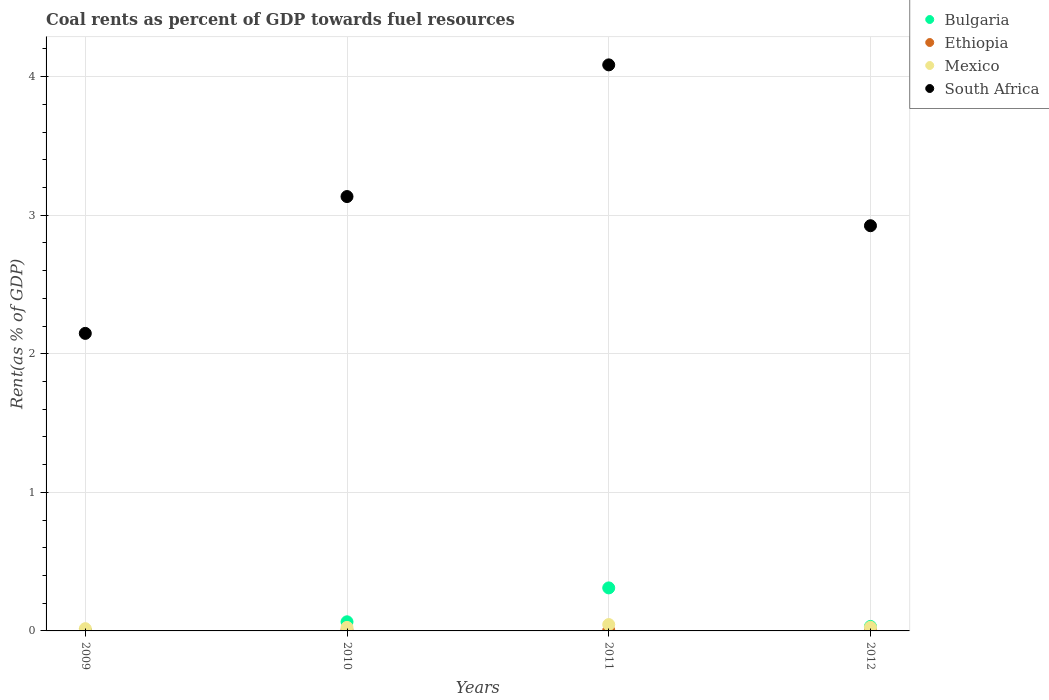Is the number of dotlines equal to the number of legend labels?
Offer a very short reply. Yes. What is the coal rent in Mexico in 2010?
Keep it short and to the point. 0.03. Across all years, what is the maximum coal rent in South Africa?
Make the answer very short. 4.08. Across all years, what is the minimum coal rent in Mexico?
Your response must be concise. 0.02. In which year was the coal rent in Mexico maximum?
Offer a terse response. 2011. What is the total coal rent in Bulgaria in the graph?
Provide a succinct answer. 0.41. What is the difference between the coal rent in Ethiopia in 2011 and that in 2012?
Your response must be concise. 0. What is the difference between the coal rent in South Africa in 2011 and the coal rent in Ethiopia in 2009?
Make the answer very short. 4.08. What is the average coal rent in Bulgaria per year?
Offer a very short reply. 0.1. In the year 2010, what is the difference between the coal rent in Mexico and coal rent in South Africa?
Your response must be concise. -3.11. In how many years, is the coal rent in Bulgaria greater than 2.6 %?
Your answer should be very brief. 0. What is the ratio of the coal rent in South Africa in 2009 to that in 2012?
Your answer should be compact. 0.73. Is the coal rent in Ethiopia in 2010 less than that in 2011?
Offer a very short reply. No. Is the difference between the coal rent in Mexico in 2010 and 2012 greater than the difference between the coal rent in South Africa in 2010 and 2012?
Offer a terse response. No. What is the difference between the highest and the second highest coal rent in Mexico?
Give a very brief answer. 0.02. What is the difference between the highest and the lowest coal rent in Bulgaria?
Give a very brief answer. 0.31. Is the sum of the coal rent in Mexico in 2010 and 2012 greater than the maximum coal rent in Bulgaria across all years?
Offer a very short reply. No. Is it the case that in every year, the sum of the coal rent in Mexico and coal rent in Bulgaria  is greater than the sum of coal rent in South Africa and coal rent in Ethiopia?
Provide a short and direct response. No. Does the coal rent in Mexico monotonically increase over the years?
Make the answer very short. No. Is the coal rent in South Africa strictly less than the coal rent in Mexico over the years?
Your answer should be compact. No. How many dotlines are there?
Provide a succinct answer. 4. Are the values on the major ticks of Y-axis written in scientific E-notation?
Your answer should be very brief. No. Does the graph contain any zero values?
Provide a succinct answer. No. Does the graph contain grids?
Keep it short and to the point. Yes. How are the legend labels stacked?
Provide a short and direct response. Vertical. What is the title of the graph?
Offer a very short reply. Coal rents as percent of GDP towards fuel resources. Does "Singapore" appear as one of the legend labels in the graph?
Offer a very short reply. No. What is the label or title of the X-axis?
Your answer should be very brief. Years. What is the label or title of the Y-axis?
Make the answer very short. Rent(as % of GDP). What is the Rent(as % of GDP) in Bulgaria in 2009?
Your answer should be compact. 0. What is the Rent(as % of GDP) in Ethiopia in 2009?
Your answer should be compact. 0. What is the Rent(as % of GDP) of Mexico in 2009?
Provide a succinct answer. 0.02. What is the Rent(as % of GDP) of South Africa in 2009?
Offer a very short reply. 2.15. What is the Rent(as % of GDP) in Bulgaria in 2010?
Offer a terse response. 0.07. What is the Rent(as % of GDP) of Ethiopia in 2010?
Provide a short and direct response. 0.01. What is the Rent(as % of GDP) of Mexico in 2010?
Offer a terse response. 0.03. What is the Rent(as % of GDP) of South Africa in 2010?
Make the answer very short. 3.13. What is the Rent(as % of GDP) in Bulgaria in 2011?
Your answer should be very brief. 0.31. What is the Rent(as % of GDP) of Ethiopia in 2011?
Ensure brevity in your answer.  0. What is the Rent(as % of GDP) of Mexico in 2011?
Keep it short and to the point. 0.05. What is the Rent(as % of GDP) of South Africa in 2011?
Make the answer very short. 4.08. What is the Rent(as % of GDP) of Bulgaria in 2012?
Make the answer very short. 0.03. What is the Rent(as % of GDP) of Ethiopia in 2012?
Provide a short and direct response. 0. What is the Rent(as % of GDP) of Mexico in 2012?
Give a very brief answer. 0.03. What is the Rent(as % of GDP) in South Africa in 2012?
Keep it short and to the point. 2.92. Across all years, what is the maximum Rent(as % of GDP) in Bulgaria?
Provide a short and direct response. 0.31. Across all years, what is the maximum Rent(as % of GDP) of Ethiopia?
Make the answer very short. 0.01. Across all years, what is the maximum Rent(as % of GDP) of Mexico?
Your answer should be compact. 0.05. Across all years, what is the maximum Rent(as % of GDP) of South Africa?
Make the answer very short. 4.08. Across all years, what is the minimum Rent(as % of GDP) in Bulgaria?
Ensure brevity in your answer.  0. Across all years, what is the minimum Rent(as % of GDP) of Ethiopia?
Your answer should be very brief. 0. Across all years, what is the minimum Rent(as % of GDP) in Mexico?
Your answer should be very brief. 0.02. Across all years, what is the minimum Rent(as % of GDP) in South Africa?
Offer a terse response. 2.15. What is the total Rent(as % of GDP) of Bulgaria in the graph?
Give a very brief answer. 0.41. What is the total Rent(as % of GDP) of Ethiopia in the graph?
Ensure brevity in your answer.  0.01. What is the total Rent(as % of GDP) in Mexico in the graph?
Your answer should be very brief. 0.11. What is the total Rent(as % of GDP) of South Africa in the graph?
Offer a terse response. 12.29. What is the difference between the Rent(as % of GDP) of Bulgaria in 2009 and that in 2010?
Your answer should be very brief. -0.07. What is the difference between the Rent(as % of GDP) of Ethiopia in 2009 and that in 2010?
Your answer should be compact. -0. What is the difference between the Rent(as % of GDP) of Mexico in 2009 and that in 2010?
Offer a terse response. -0.01. What is the difference between the Rent(as % of GDP) in South Africa in 2009 and that in 2010?
Offer a terse response. -0.99. What is the difference between the Rent(as % of GDP) of Bulgaria in 2009 and that in 2011?
Make the answer very short. -0.31. What is the difference between the Rent(as % of GDP) in Ethiopia in 2009 and that in 2011?
Provide a succinct answer. -0. What is the difference between the Rent(as % of GDP) of Mexico in 2009 and that in 2011?
Offer a terse response. -0.03. What is the difference between the Rent(as % of GDP) in South Africa in 2009 and that in 2011?
Ensure brevity in your answer.  -1.94. What is the difference between the Rent(as % of GDP) in Bulgaria in 2009 and that in 2012?
Your answer should be compact. -0.03. What is the difference between the Rent(as % of GDP) in Ethiopia in 2009 and that in 2012?
Offer a terse response. -0. What is the difference between the Rent(as % of GDP) of Mexico in 2009 and that in 2012?
Your answer should be very brief. -0.01. What is the difference between the Rent(as % of GDP) in South Africa in 2009 and that in 2012?
Provide a short and direct response. -0.78. What is the difference between the Rent(as % of GDP) of Bulgaria in 2010 and that in 2011?
Ensure brevity in your answer.  -0.24. What is the difference between the Rent(as % of GDP) in Ethiopia in 2010 and that in 2011?
Make the answer very short. 0. What is the difference between the Rent(as % of GDP) in Mexico in 2010 and that in 2011?
Your answer should be very brief. -0.02. What is the difference between the Rent(as % of GDP) of South Africa in 2010 and that in 2011?
Your response must be concise. -0.95. What is the difference between the Rent(as % of GDP) of Bulgaria in 2010 and that in 2012?
Provide a short and direct response. 0.03. What is the difference between the Rent(as % of GDP) of Ethiopia in 2010 and that in 2012?
Provide a short and direct response. 0. What is the difference between the Rent(as % of GDP) of Mexico in 2010 and that in 2012?
Your answer should be compact. -0. What is the difference between the Rent(as % of GDP) of South Africa in 2010 and that in 2012?
Provide a succinct answer. 0.21. What is the difference between the Rent(as % of GDP) in Bulgaria in 2011 and that in 2012?
Your answer should be compact. 0.28. What is the difference between the Rent(as % of GDP) in Ethiopia in 2011 and that in 2012?
Your answer should be very brief. 0. What is the difference between the Rent(as % of GDP) of Mexico in 2011 and that in 2012?
Keep it short and to the point. 0.02. What is the difference between the Rent(as % of GDP) in South Africa in 2011 and that in 2012?
Your answer should be compact. 1.16. What is the difference between the Rent(as % of GDP) of Bulgaria in 2009 and the Rent(as % of GDP) of Ethiopia in 2010?
Your answer should be very brief. -0. What is the difference between the Rent(as % of GDP) of Bulgaria in 2009 and the Rent(as % of GDP) of Mexico in 2010?
Give a very brief answer. -0.02. What is the difference between the Rent(as % of GDP) of Bulgaria in 2009 and the Rent(as % of GDP) of South Africa in 2010?
Offer a terse response. -3.13. What is the difference between the Rent(as % of GDP) of Ethiopia in 2009 and the Rent(as % of GDP) of Mexico in 2010?
Make the answer very short. -0.02. What is the difference between the Rent(as % of GDP) of Ethiopia in 2009 and the Rent(as % of GDP) of South Africa in 2010?
Offer a very short reply. -3.13. What is the difference between the Rent(as % of GDP) in Mexico in 2009 and the Rent(as % of GDP) in South Africa in 2010?
Provide a short and direct response. -3.12. What is the difference between the Rent(as % of GDP) in Bulgaria in 2009 and the Rent(as % of GDP) in Ethiopia in 2011?
Provide a succinct answer. -0. What is the difference between the Rent(as % of GDP) in Bulgaria in 2009 and the Rent(as % of GDP) in Mexico in 2011?
Ensure brevity in your answer.  -0.05. What is the difference between the Rent(as % of GDP) in Bulgaria in 2009 and the Rent(as % of GDP) in South Africa in 2011?
Offer a terse response. -4.08. What is the difference between the Rent(as % of GDP) in Ethiopia in 2009 and the Rent(as % of GDP) in Mexico in 2011?
Give a very brief answer. -0.04. What is the difference between the Rent(as % of GDP) in Ethiopia in 2009 and the Rent(as % of GDP) in South Africa in 2011?
Provide a short and direct response. -4.08. What is the difference between the Rent(as % of GDP) in Mexico in 2009 and the Rent(as % of GDP) in South Africa in 2011?
Ensure brevity in your answer.  -4.07. What is the difference between the Rent(as % of GDP) of Bulgaria in 2009 and the Rent(as % of GDP) of Ethiopia in 2012?
Your answer should be very brief. -0. What is the difference between the Rent(as % of GDP) of Bulgaria in 2009 and the Rent(as % of GDP) of Mexico in 2012?
Provide a succinct answer. -0.03. What is the difference between the Rent(as % of GDP) in Bulgaria in 2009 and the Rent(as % of GDP) in South Africa in 2012?
Make the answer very short. -2.92. What is the difference between the Rent(as % of GDP) of Ethiopia in 2009 and the Rent(as % of GDP) of Mexico in 2012?
Your answer should be compact. -0.03. What is the difference between the Rent(as % of GDP) in Ethiopia in 2009 and the Rent(as % of GDP) in South Africa in 2012?
Keep it short and to the point. -2.92. What is the difference between the Rent(as % of GDP) in Mexico in 2009 and the Rent(as % of GDP) in South Africa in 2012?
Your answer should be very brief. -2.91. What is the difference between the Rent(as % of GDP) in Bulgaria in 2010 and the Rent(as % of GDP) in Ethiopia in 2011?
Ensure brevity in your answer.  0.06. What is the difference between the Rent(as % of GDP) of Bulgaria in 2010 and the Rent(as % of GDP) of Mexico in 2011?
Keep it short and to the point. 0.02. What is the difference between the Rent(as % of GDP) of Bulgaria in 2010 and the Rent(as % of GDP) of South Africa in 2011?
Your answer should be compact. -4.02. What is the difference between the Rent(as % of GDP) in Ethiopia in 2010 and the Rent(as % of GDP) in Mexico in 2011?
Provide a succinct answer. -0.04. What is the difference between the Rent(as % of GDP) of Ethiopia in 2010 and the Rent(as % of GDP) of South Africa in 2011?
Your answer should be compact. -4.08. What is the difference between the Rent(as % of GDP) of Mexico in 2010 and the Rent(as % of GDP) of South Africa in 2011?
Your answer should be compact. -4.06. What is the difference between the Rent(as % of GDP) in Bulgaria in 2010 and the Rent(as % of GDP) in Ethiopia in 2012?
Your response must be concise. 0.06. What is the difference between the Rent(as % of GDP) of Bulgaria in 2010 and the Rent(as % of GDP) of Mexico in 2012?
Ensure brevity in your answer.  0.04. What is the difference between the Rent(as % of GDP) of Bulgaria in 2010 and the Rent(as % of GDP) of South Africa in 2012?
Ensure brevity in your answer.  -2.86. What is the difference between the Rent(as % of GDP) of Ethiopia in 2010 and the Rent(as % of GDP) of Mexico in 2012?
Provide a short and direct response. -0.02. What is the difference between the Rent(as % of GDP) in Ethiopia in 2010 and the Rent(as % of GDP) in South Africa in 2012?
Your answer should be very brief. -2.92. What is the difference between the Rent(as % of GDP) in Mexico in 2010 and the Rent(as % of GDP) in South Africa in 2012?
Your answer should be very brief. -2.9. What is the difference between the Rent(as % of GDP) in Bulgaria in 2011 and the Rent(as % of GDP) in Ethiopia in 2012?
Give a very brief answer. 0.31. What is the difference between the Rent(as % of GDP) in Bulgaria in 2011 and the Rent(as % of GDP) in Mexico in 2012?
Give a very brief answer. 0.28. What is the difference between the Rent(as % of GDP) of Bulgaria in 2011 and the Rent(as % of GDP) of South Africa in 2012?
Ensure brevity in your answer.  -2.61. What is the difference between the Rent(as % of GDP) in Ethiopia in 2011 and the Rent(as % of GDP) in Mexico in 2012?
Ensure brevity in your answer.  -0.02. What is the difference between the Rent(as % of GDP) of Ethiopia in 2011 and the Rent(as % of GDP) of South Africa in 2012?
Ensure brevity in your answer.  -2.92. What is the difference between the Rent(as % of GDP) in Mexico in 2011 and the Rent(as % of GDP) in South Africa in 2012?
Keep it short and to the point. -2.88. What is the average Rent(as % of GDP) in Bulgaria per year?
Keep it short and to the point. 0.1. What is the average Rent(as % of GDP) of Ethiopia per year?
Ensure brevity in your answer.  0. What is the average Rent(as % of GDP) of Mexico per year?
Provide a short and direct response. 0.03. What is the average Rent(as % of GDP) in South Africa per year?
Provide a succinct answer. 3.07. In the year 2009, what is the difference between the Rent(as % of GDP) in Bulgaria and Rent(as % of GDP) in Ethiopia?
Offer a terse response. -0. In the year 2009, what is the difference between the Rent(as % of GDP) in Bulgaria and Rent(as % of GDP) in Mexico?
Make the answer very short. -0.02. In the year 2009, what is the difference between the Rent(as % of GDP) of Bulgaria and Rent(as % of GDP) of South Africa?
Make the answer very short. -2.15. In the year 2009, what is the difference between the Rent(as % of GDP) in Ethiopia and Rent(as % of GDP) in Mexico?
Give a very brief answer. -0.01. In the year 2009, what is the difference between the Rent(as % of GDP) in Ethiopia and Rent(as % of GDP) in South Africa?
Make the answer very short. -2.15. In the year 2009, what is the difference between the Rent(as % of GDP) of Mexico and Rent(as % of GDP) of South Africa?
Make the answer very short. -2.13. In the year 2010, what is the difference between the Rent(as % of GDP) of Bulgaria and Rent(as % of GDP) of Ethiopia?
Your answer should be compact. 0.06. In the year 2010, what is the difference between the Rent(as % of GDP) of Bulgaria and Rent(as % of GDP) of Mexico?
Provide a succinct answer. 0.04. In the year 2010, what is the difference between the Rent(as % of GDP) of Bulgaria and Rent(as % of GDP) of South Africa?
Give a very brief answer. -3.07. In the year 2010, what is the difference between the Rent(as % of GDP) in Ethiopia and Rent(as % of GDP) in Mexico?
Offer a very short reply. -0.02. In the year 2010, what is the difference between the Rent(as % of GDP) of Ethiopia and Rent(as % of GDP) of South Africa?
Offer a very short reply. -3.13. In the year 2010, what is the difference between the Rent(as % of GDP) in Mexico and Rent(as % of GDP) in South Africa?
Keep it short and to the point. -3.11. In the year 2011, what is the difference between the Rent(as % of GDP) of Bulgaria and Rent(as % of GDP) of Ethiopia?
Give a very brief answer. 0.31. In the year 2011, what is the difference between the Rent(as % of GDP) of Bulgaria and Rent(as % of GDP) of Mexico?
Ensure brevity in your answer.  0.26. In the year 2011, what is the difference between the Rent(as % of GDP) in Bulgaria and Rent(as % of GDP) in South Africa?
Ensure brevity in your answer.  -3.77. In the year 2011, what is the difference between the Rent(as % of GDP) of Ethiopia and Rent(as % of GDP) of Mexico?
Make the answer very short. -0.04. In the year 2011, what is the difference between the Rent(as % of GDP) of Ethiopia and Rent(as % of GDP) of South Africa?
Your answer should be very brief. -4.08. In the year 2011, what is the difference between the Rent(as % of GDP) of Mexico and Rent(as % of GDP) of South Africa?
Your answer should be compact. -4.04. In the year 2012, what is the difference between the Rent(as % of GDP) of Bulgaria and Rent(as % of GDP) of Ethiopia?
Ensure brevity in your answer.  0.03. In the year 2012, what is the difference between the Rent(as % of GDP) in Bulgaria and Rent(as % of GDP) in Mexico?
Provide a short and direct response. 0.01. In the year 2012, what is the difference between the Rent(as % of GDP) in Bulgaria and Rent(as % of GDP) in South Africa?
Your response must be concise. -2.89. In the year 2012, what is the difference between the Rent(as % of GDP) of Ethiopia and Rent(as % of GDP) of Mexico?
Ensure brevity in your answer.  -0.02. In the year 2012, what is the difference between the Rent(as % of GDP) in Ethiopia and Rent(as % of GDP) in South Africa?
Make the answer very short. -2.92. In the year 2012, what is the difference between the Rent(as % of GDP) of Mexico and Rent(as % of GDP) of South Africa?
Ensure brevity in your answer.  -2.9. What is the ratio of the Rent(as % of GDP) in Bulgaria in 2009 to that in 2010?
Your response must be concise. 0.01. What is the ratio of the Rent(as % of GDP) in Ethiopia in 2009 to that in 2010?
Your response must be concise. 0.24. What is the ratio of the Rent(as % of GDP) of Mexico in 2009 to that in 2010?
Provide a short and direct response. 0.64. What is the ratio of the Rent(as % of GDP) in South Africa in 2009 to that in 2010?
Make the answer very short. 0.69. What is the ratio of the Rent(as % of GDP) in Bulgaria in 2009 to that in 2011?
Offer a terse response. 0. What is the ratio of the Rent(as % of GDP) in Ethiopia in 2009 to that in 2011?
Your answer should be very brief. 0.29. What is the ratio of the Rent(as % of GDP) in Mexico in 2009 to that in 2011?
Your answer should be very brief. 0.35. What is the ratio of the Rent(as % of GDP) in South Africa in 2009 to that in 2011?
Give a very brief answer. 0.53. What is the ratio of the Rent(as % of GDP) of Bulgaria in 2009 to that in 2012?
Offer a very short reply. 0.03. What is the ratio of the Rent(as % of GDP) in Ethiopia in 2009 to that in 2012?
Offer a terse response. 0.51. What is the ratio of the Rent(as % of GDP) of Mexico in 2009 to that in 2012?
Make the answer very short. 0.61. What is the ratio of the Rent(as % of GDP) in South Africa in 2009 to that in 2012?
Provide a short and direct response. 0.73. What is the ratio of the Rent(as % of GDP) in Bulgaria in 2010 to that in 2011?
Your response must be concise. 0.21. What is the ratio of the Rent(as % of GDP) in Ethiopia in 2010 to that in 2011?
Make the answer very short. 1.23. What is the ratio of the Rent(as % of GDP) of Mexico in 2010 to that in 2011?
Keep it short and to the point. 0.55. What is the ratio of the Rent(as % of GDP) in South Africa in 2010 to that in 2011?
Your answer should be compact. 0.77. What is the ratio of the Rent(as % of GDP) in Bulgaria in 2010 to that in 2012?
Offer a terse response. 2.03. What is the ratio of the Rent(as % of GDP) of Ethiopia in 2010 to that in 2012?
Offer a terse response. 2.16. What is the ratio of the Rent(as % of GDP) of Mexico in 2010 to that in 2012?
Your answer should be very brief. 0.96. What is the ratio of the Rent(as % of GDP) of South Africa in 2010 to that in 2012?
Make the answer very short. 1.07. What is the ratio of the Rent(as % of GDP) in Bulgaria in 2011 to that in 2012?
Ensure brevity in your answer.  9.6. What is the ratio of the Rent(as % of GDP) of Ethiopia in 2011 to that in 2012?
Give a very brief answer. 1.76. What is the ratio of the Rent(as % of GDP) in Mexico in 2011 to that in 2012?
Ensure brevity in your answer.  1.73. What is the ratio of the Rent(as % of GDP) of South Africa in 2011 to that in 2012?
Ensure brevity in your answer.  1.4. What is the difference between the highest and the second highest Rent(as % of GDP) of Bulgaria?
Provide a short and direct response. 0.24. What is the difference between the highest and the second highest Rent(as % of GDP) of Mexico?
Keep it short and to the point. 0.02. What is the difference between the highest and the second highest Rent(as % of GDP) in South Africa?
Make the answer very short. 0.95. What is the difference between the highest and the lowest Rent(as % of GDP) in Bulgaria?
Offer a very short reply. 0.31. What is the difference between the highest and the lowest Rent(as % of GDP) in Ethiopia?
Make the answer very short. 0. What is the difference between the highest and the lowest Rent(as % of GDP) of Mexico?
Provide a succinct answer. 0.03. What is the difference between the highest and the lowest Rent(as % of GDP) of South Africa?
Keep it short and to the point. 1.94. 